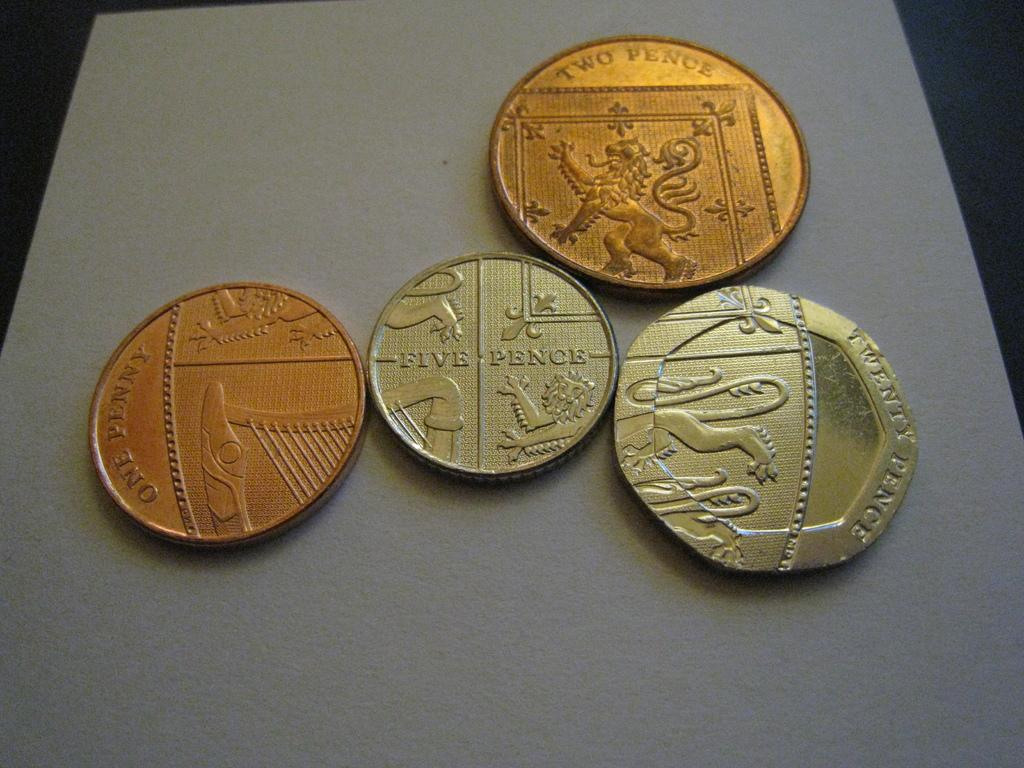<image>
Offer a succinct explanation of the picture presented. Four coins, one a five pence, one a one penny, one two pence and a twenty pence coin touch each other. 